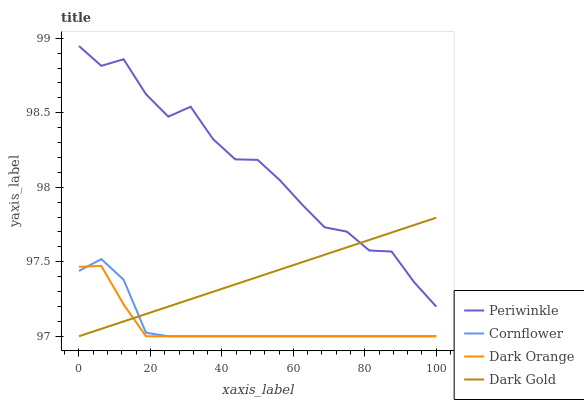Does Dark Orange have the minimum area under the curve?
Answer yes or no. Yes. Does Periwinkle have the maximum area under the curve?
Answer yes or no. Yes. Does Dark Gold have the minimum area under the curve?
Answer yes or no. No. Does Dark Gold have the maximum area under the curve?
Answer yes or no. No. Is Dark Gold the smoothest?
Answer yes or no. Yes. Is Periwinkle the roughest?
Answer yes or no. Yes. Is Periwinkle the smoothest?
Answer yes or no. No. Is Dark Gold the roughest?
Answer yes or no. No. Does Cornflower have the lowest value?
Answer yes or no. Yes. Does Periwinkle have the lowest value?
Answer yes or no. No. Does Periwinkle have the highest value?
Answer yes or no. Yes. Does Dark Gold have the highest value?
Answer yes or no. No. Is Cornflower less than Periwinkle?
Answer yes or no. Yes. Is Periwinkle greater than Cornflower?
Answer yes or no. Yes. Does Dark Gold intersect Cornflower?
Answer yes or no. Yes. Is Dark Gold less than Cornflower?
Answer yes or no. No. Is Dark Gold greater than Cornflower?
Answer yes or no. No. Does Cornflower intersect Periwinkle?
Answer yes or no. No. 